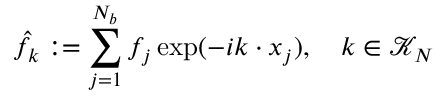Convert formula to latex. <formula><loc_0><loc_0><loc_500><loc_500>\hat { f } _ { \boldsymbol k } \colon = \sum _ { j = 1 } ^ { N _ { b } } f _ { j } \exp ( - i \boldsymbol k \cdot \boldsymbol x _ { j } ) , \quad \boldsymbol k \in \mathcal { K } _ { N }</formula> 